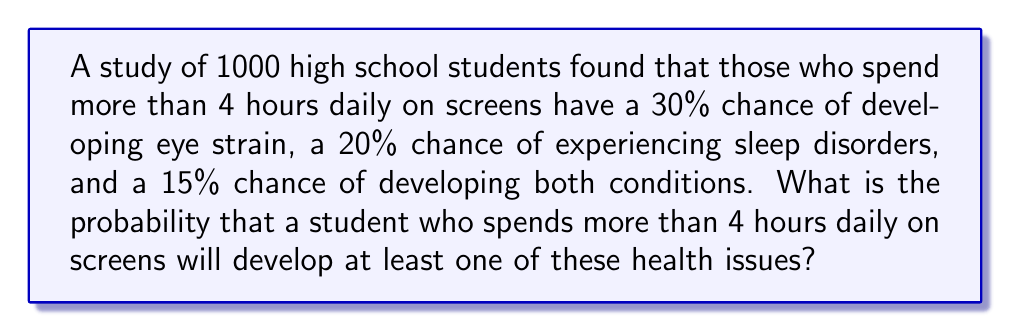Solve this math problem. To solve this problem, we'll use the addition rule of probability for non-mutually exclusive events. Let's define our events:

A: Developing eye strain (P(A) = 0.30)
B: Experiencing sleep disorders (P(B) = 0.20)

We're given that P(A ∩ B) = 0.15 (the probability of developing both conditions)

The formula for the probability of at least one of these events occurring is:

$$ P(A \cup B) = P(A) + P(B) - P(A \cap B) $$

Substituting the values:

$$ P(A \cup B) = 0.30 + 0.20 - 0.15 $$

$$ P(A \cup B) = 0.50 - 0.15 $$

$$ P(A \cup B) = 0.35 $$

Therefore, the probability of a student developing at least one of these health issues is 0.35 or 35%.
Answer: 0.35 or 35% 